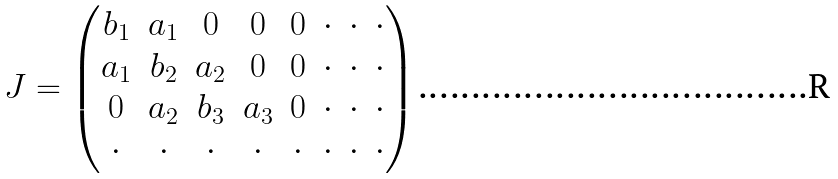<formula> <loc_0><loc_0><loc_500><loc_500>J = \begin{pmatrix} b _ { 1 } & a _ { 1 } & 0 & 0 & 0 & \cdot & \cdot & \cdot \\ a _ { 1 } & b _ { 2 } & a _ { 2 } & 0 & 0 & \cdot & \cdot & \cdot \\ 0 & a _ { 2 } & b _ { 3 } & a _ { 3 } & 0 & \cdot & \cdot & \cdot \\ \cdot & \cdot & \cdot & \cdot & \cdot & \cdot & \cdot & \cdot \end{pmatrix}</formula> 